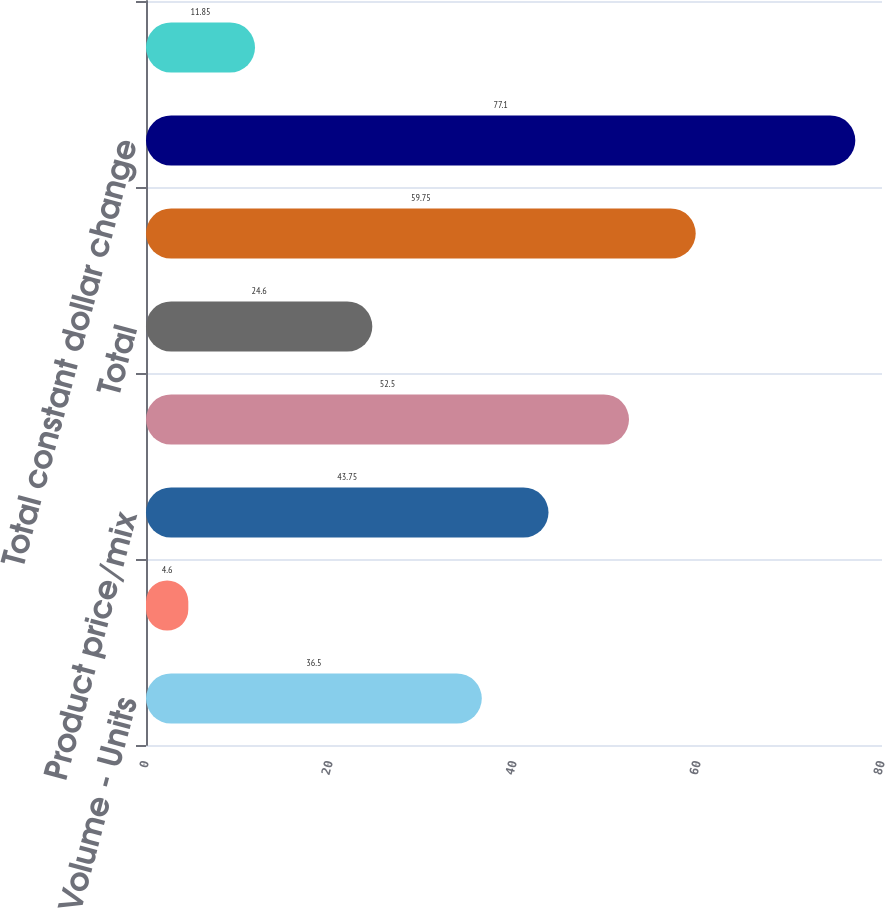Convert chart. <chart><loc_0><loc_0><loc_500><loc_500><bar_chart><fcel>Volume - Units<fcel>change<fcel>Product price/mix<fcel>Foreign currency translation<fcel>Total<fcel>Impact of foreign currency<fcel>Total constant dollar change<fcel>Constant dollar change<nl><fcel>36.5<fcel>4.6<fcel>43.75<fcel>52.5<fcel>24.6<fcel>59.75<fcel>77.1<fcel>11.85<nl></chart> 